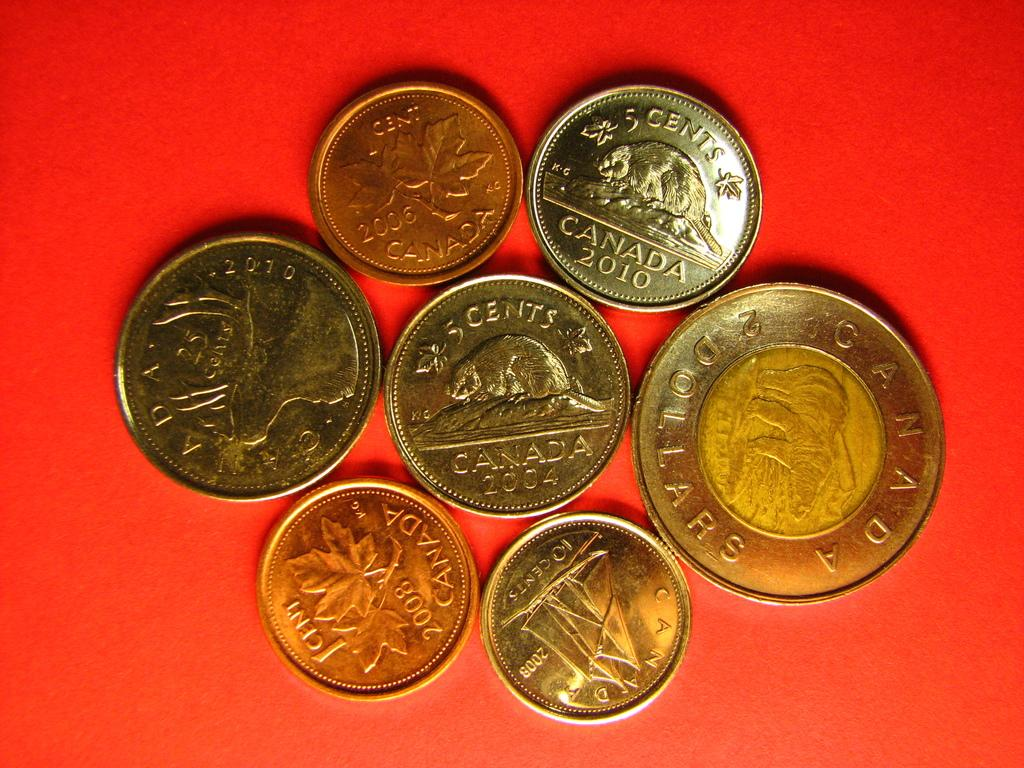<image>
Relay a brief, clear account of the picture shown. a coin with the word cents at the top 